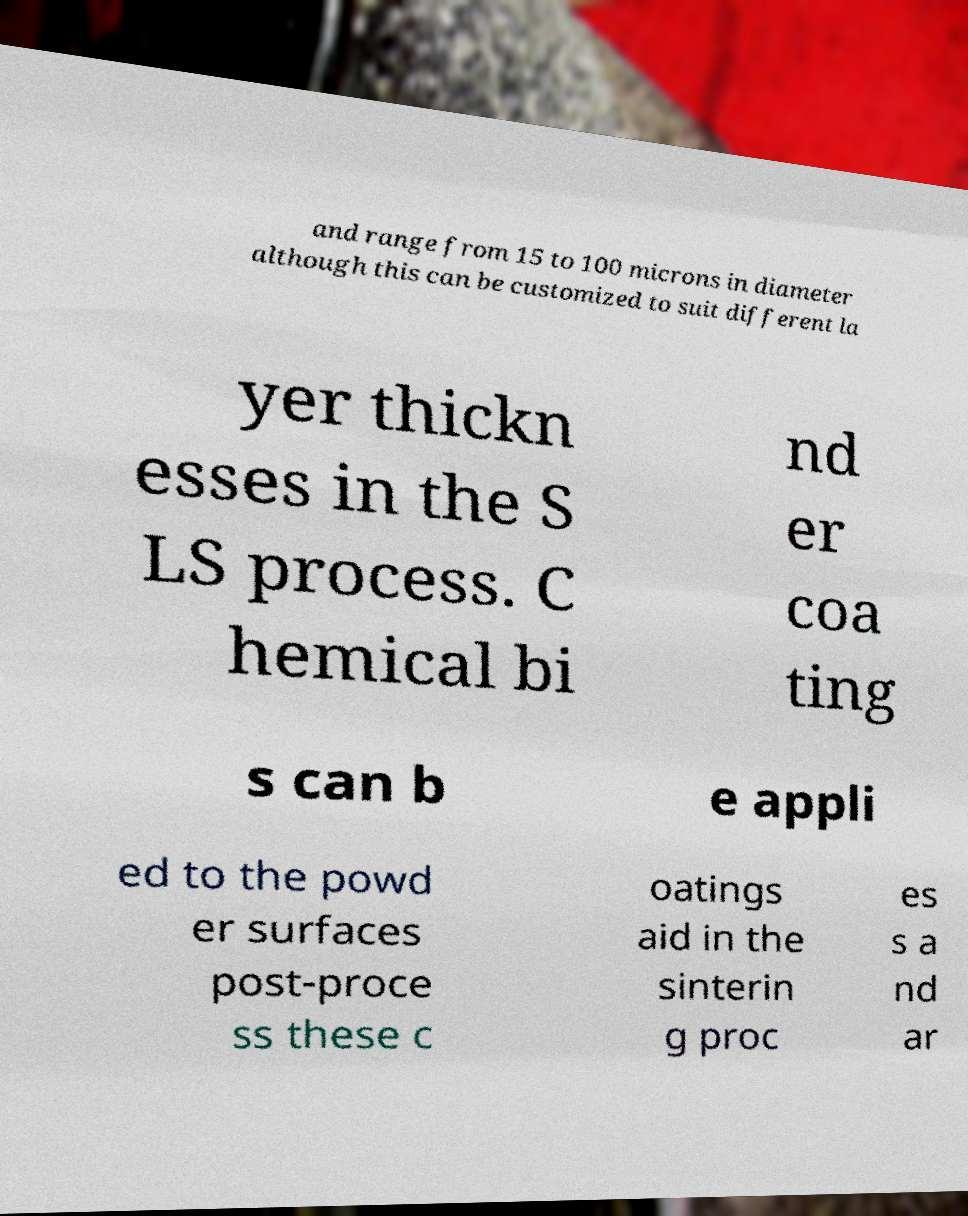Please read and relay the text visible in this image. What does it say? and range from 15 to 100 microns in diameter although this can be customized to suit different la yer thickn esses in the S LS process. C hemical bi nd er coa ting s can b e appli ed to the powd er surfaces post-proce ss these c oatings aid in the sinterin g proc es s a nd ar 